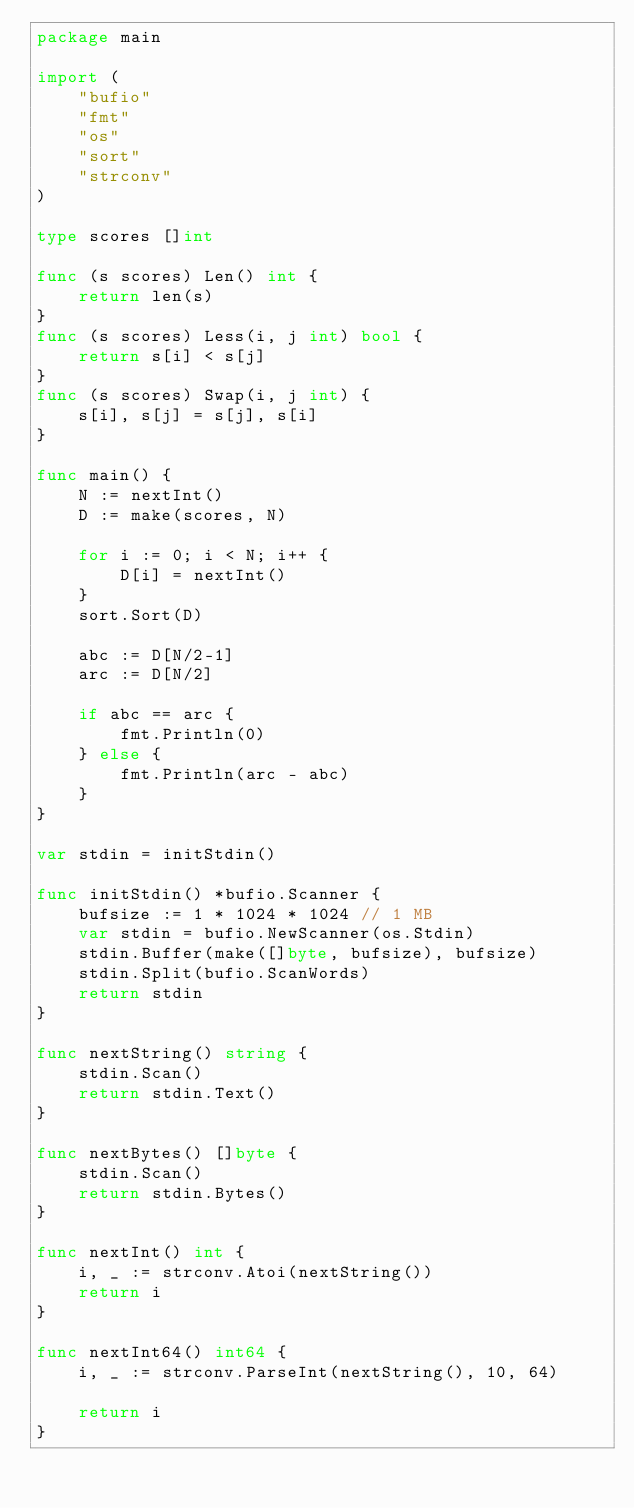Convert code to text. <code><loc_0><loc_0><loc_500><loc_500><_Go_>package main

import (
	"bufio"
	"fmt"
	"os"
	"sort"
	"strconv"
)

type scores []int

func (s scores) Len() int {
	return len(s)
}
func (s scores) Less(i, j int) bool {
	return s[i] < s[j]
}
func (s scores) Swap(i, j int) {
	s[i], s[j] = s[j], s[i]
}

func main() {
	N := nextInt()
	D := make(scores, N)

	for i := 0; i < N; i++ {
		D[i] = nextInt()
	}
	sort.Sort(D)

	abc := D[N/2-1]
	arc := D[N/2]

	if abc == arc {
		fmt.Println(0)
	} else {
		fmt.Println(arc - abc)
	}
}

var stdin = initStdin()

func initStdin() *bufio.Scanner {
	bufsize := 1 * 1024 * 1024 // 1 MB
	var stdin = bufio.NewScanner(os.Stdin)
	stdin.Buffer(make([]byte, bufsize), bufsize)
	stdin.Split(bufio.ScanWords)
	return stdin
}

func nextString() string {
	stdin.Scan()
	return stdin.Text()
}

func nextBytes() []byte {
	stdin.Scan()
	return stdin.Bytes()
}

func nextInt() int {
	i, _ := strconv.Atoi(nextString())
	return i
}

func nextInt64() int64 {
	i, _ := strconv.ParseInt(nextString(), 10, 64)

	return i
}
</code> 